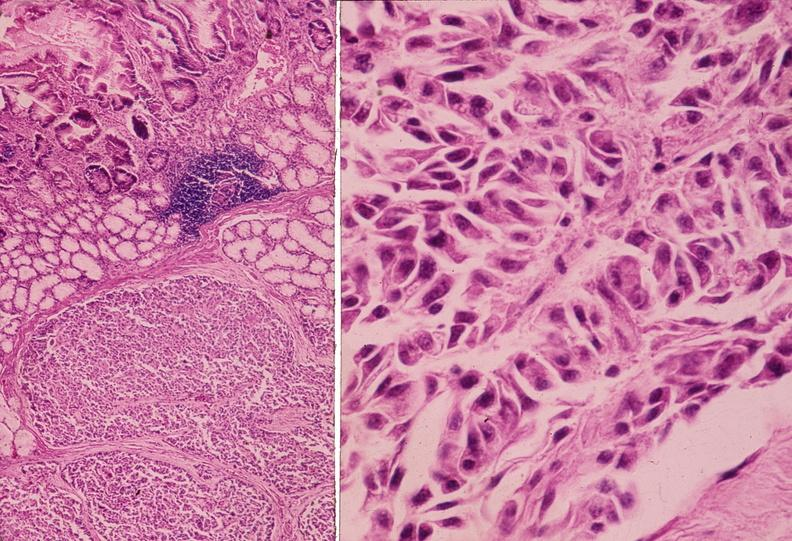s periaortic nodes with metastatic carcinoma aorta present?
Answer the question using a single word or phrase. No 